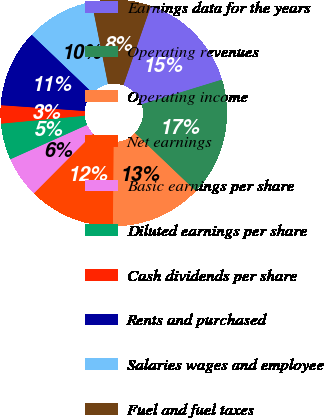Convert chart to OTSL. <chart><loc_0><loc_0><loc_500><loc_500><pie_chart><fcel>Earnings data for the years<fcel>Operating revenues<fcel>Operating income<fcel>Net earnings<fcel>Basic earnings per share<fcel>Diluted earnings per share<fcel>Cash dividends per share<fcel>Rents and purchased<fcel>Salaries wages and employee<fcel>Fuel and fuel taxes<nl><fcel>14.93%<fcel>16.88%<fcel>12.99%<fcel>12.34%<fcel>5.84%<fcel>5.2%<fcel>2.6%<fcel>11.04%<fcel>9.74%<fcel>8.44%<nl></chart> 